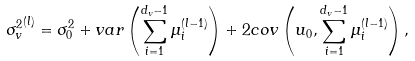<formula> <loc_0><loc_0><loc_500><loc_500>{ \sigma ^ { 2 } _ { v } } ^ { ( l ) } = \sigma ^ { 2 } _ { 0 } + v a r \left ( \sum _ { i = 1 } ^ { d _ { v } - 1 } \mu _ { i } ^ { ( l - 1 ) } \right ) + 2 c o v \left ( u _ { 0 } , \sum _ { i = 1 } ^ { d _ { v } - 1 } \mu _ { i } ^ { ( l - 1 ) } \right ) ,</formula> 